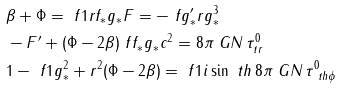Convert formula to latex. <formula><loc_0><loc_0><loc_500><loc_500>& \beta + \Phi = \ f { 1 } { r f _ { * } g _ { * } } F = - \ f { g _ { * } ^ { \prime } } { r g _ { * } ^ { 3 } } \\ & - F ^ { \prime } + ( \Phi - 2 \beta ) \ f { f _ { * } g _ { * } } { c ^ { 2 } } = 8 \pi \ G N \, \tau ^ { 0 } _ { t r } \\ & 1 - \ f 1 { g _ { * } ^ { 2 } } + r ^ { 2 } ( \Phi - 2 \beta ) = \ f 1 { i \sin \ t h } \, 8 \pi \ G N \, \tau ^ { 0 } _ { \ t h \phi }</formula> 